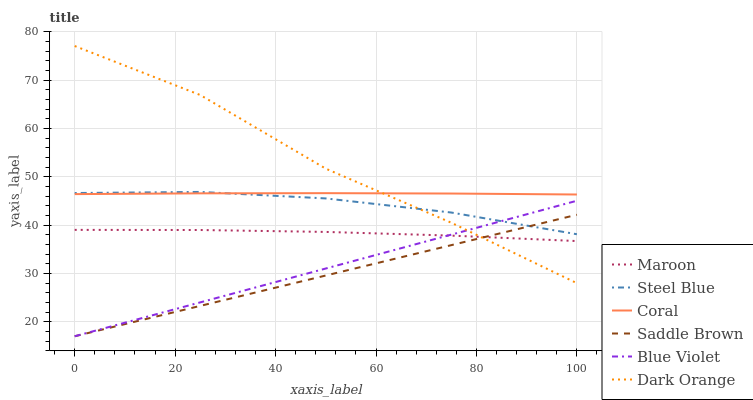Does Saddle Brown have the minimum area under the curve?
Answer yes or no. Yes. Does Dark Orange have the maximum area under the curve?
Answer yes or no. Yes. Does Coral have the minimum area under the curve?
Answer yes or no. No. Does Coral have the maximum area under the curve?
Answer yes or no. No. Is Blue Violet the smoothest?
Answer yes or no. Yes. Is Dark Orange the roughest?
Answer yes or no. Yes. Is Coral the smoothest?
Answer yes or no. No. Is Coral the roughest?
Answer yes or no. No. Does Saddle Brown have the lowest value?
Answer yes or no. Yes. Does Steel Blue have the lowest value?
Answer yes or no. No. Does Dark Orange have the highest value?
Answer yes or no. Yes. Does Coral have the highest value?
Answer yes or no. No. Is Maroon less than Steel Blue?
Answer yes or no. Yes. Is Coral greater than Saddle Brown?
Answer yes or no. Yes. Does Dark Orange intersect Coral?
Answer yes or no. Yes. Is Dark Orange less than Coral?
Answer yes or no. No. Is Dark Orange greater than Coral?
Answer yes or no. No. Does Maroon intersect Steel Blue?
Answer yes or no. No. 